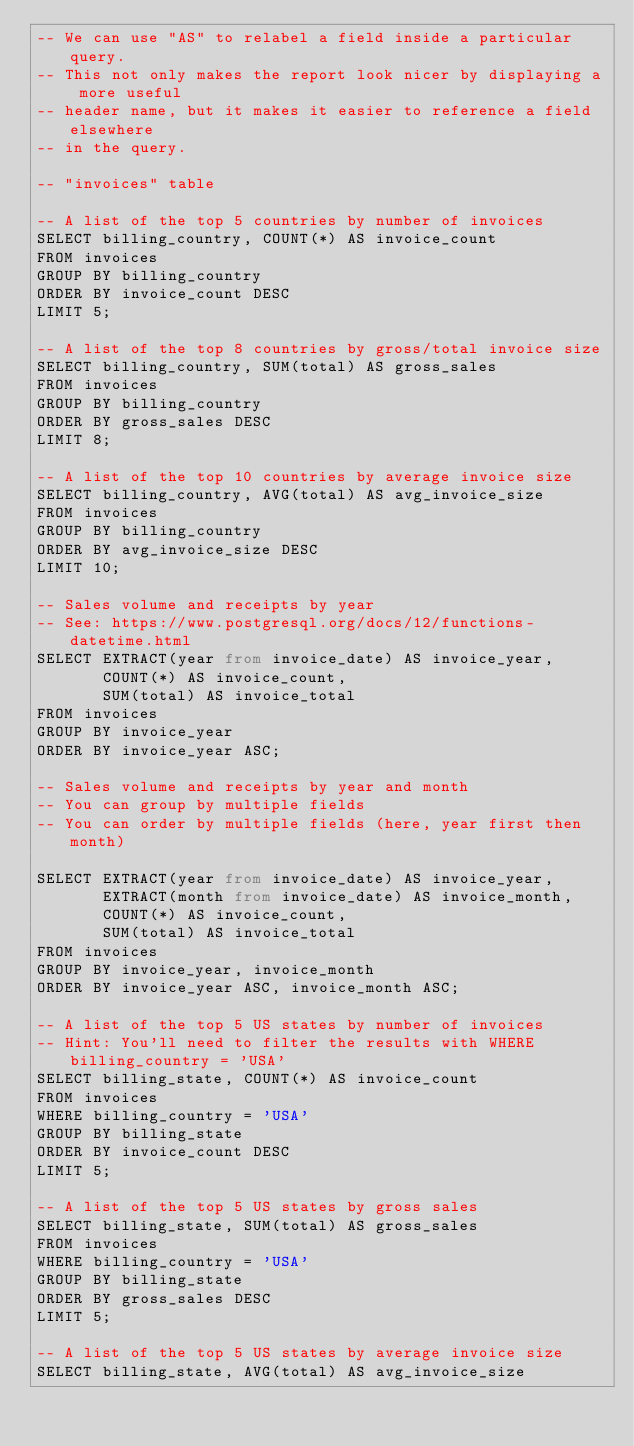<code> <loc_0><loc_0><loc_500><loc_500><_SQL_>-- We can use "AS" to relabel a field inside a particular query.
-- This not only makes the report look nicer by displaying a more useful
-- header name, but it makes it easier to reference a field elsewhere
-- in the query.

-- "invoices" table

-- A list of the top 5 countries by number of invoices
SELECT billing_country, COUNT(*) AS invoice_count
FROM invoices
GROUP BY billing_country
ORDER BY invoice_count DESC
LIMIT 5;

-- A list of the top 8 countries by gross/total invoice size
SELECT billing_country, SUM(total) AS gross_sales
FROM invoices
GROUP BY billing_country
ORDER BY gross_sales DESC
LIMIT 8;

-- A list of the top 10 countries by average invoice size
SELECT billing_country, AVG(total) AS avg_invoice_size
FROM invoices
GROUP BY billing_country
ORDER BY avg_invoice_size DESC
LIMIT 10;

-- Sales volume and receipts by year
-- See: https://www.postgresql.org/docs/12/functions-datetime.html
SELECT EXTRACT(year from invoice_date) AS invoice_year,
       COUNT(*) AS invoice_count,
       SUM(total) AS invoice_total
FROM invoices
GROUP BY invoice_year
ORDER BY invoice_year ASC;

-- Sales volume and receipts by year and month
-- You can group by multiple fields
-- You can order by multiple fields (here, year first then month)

SELECT EXTRACT(year from invoice_date) AS invoice_year,
       EXTRACT(month from invoice_date) AS invoice_month,
       COUNT(*) AS invoice_count,
       SUM(total) AS invoice_total
FROM invoices
GROUP BY invoice_year, invoice_month
ORDER BY invoice_year ASC, invoice_month ASC;

-- A list of the top 5 US states by number of invoices
-- Hint: You'll need to filter the results with WHERE billing_country = 'USA'
SELECT billing_state, COUNT(*) AS invoice_count
FROM invoices
WHERE billing_country = 'USA'
GROUP BY billing_state
ORDER BY invoice_count DESC
LIMIT 5;

-- A list of the top 5 US states by gross sales
SELECT billing_state, SUM(total) AS gross_sales
FROM invoices
WHERE billing_country = 'USA'
GROUP BY billing_state
ORDER BY gross_sales DESC
LIMIT 5;

-- A list of the top 5 US states by average invoice size
SELECT billing_state, AVG(total) AS avg_invoice_size</code> 